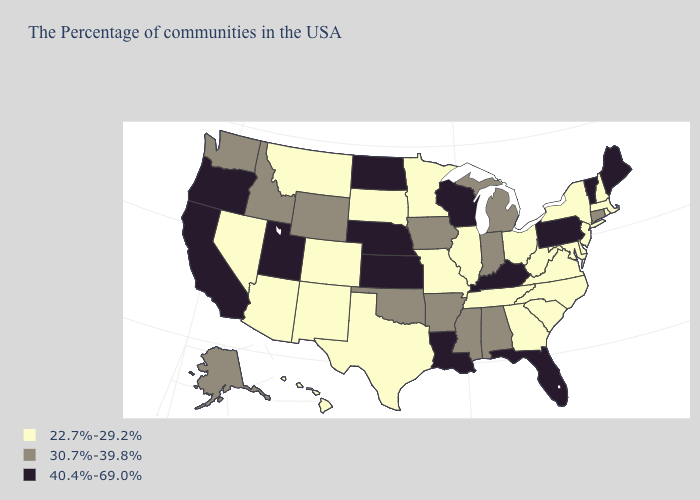Does Montana have the lowest value in the West?
Be succinct. Yes. Which states hav the highest value in the MidWest?
Write a very short answer. Wisconsin, Kansas, Nebraska, North Dakota. What is the lowest value in states that border Connecticut?
Keep it brief. 22.7%-29.2%. What is the value of West Virginia?
Keep it brief. 22.7%-29.2%. What is the lowest value in states that border Washington?
Be succinct. 30.7%-39.8%. Does South Carolina have the lowest value in the USA?
Answer briefly. Yes. Which states hav the highest value in the Northeast?
Give a very brief answer. Maine, Vermont, Pennsylvania. What is the value of Kansas?
Quick response, please. 40.4%-69.0%. What is the value of Massachusetts?
Keep it brief. 22.7%-29.2%. Does Georgia have the lowest value in the South?
Concise answer only. Yes. Does Louisiana have the highest value in the USA?
Give a very brief answer. Yes. What is the highest value in the South ?
Short answer required. 40.4%-69.0%. Does West Virginia have a lower value than Virginia?
Keep it brief. No. Name the states that have a value in the range 40.4%-69.0%?
Answer briefly. Maine, Vermont, Pennsylvania, Florida, Kentucky, Wisconsin, Louisiana, Kansas, Nebraska, North Dakota, Utah, California, Oregon. Does Montana have the lowest value in the West?
Keep it brief. Yes. 